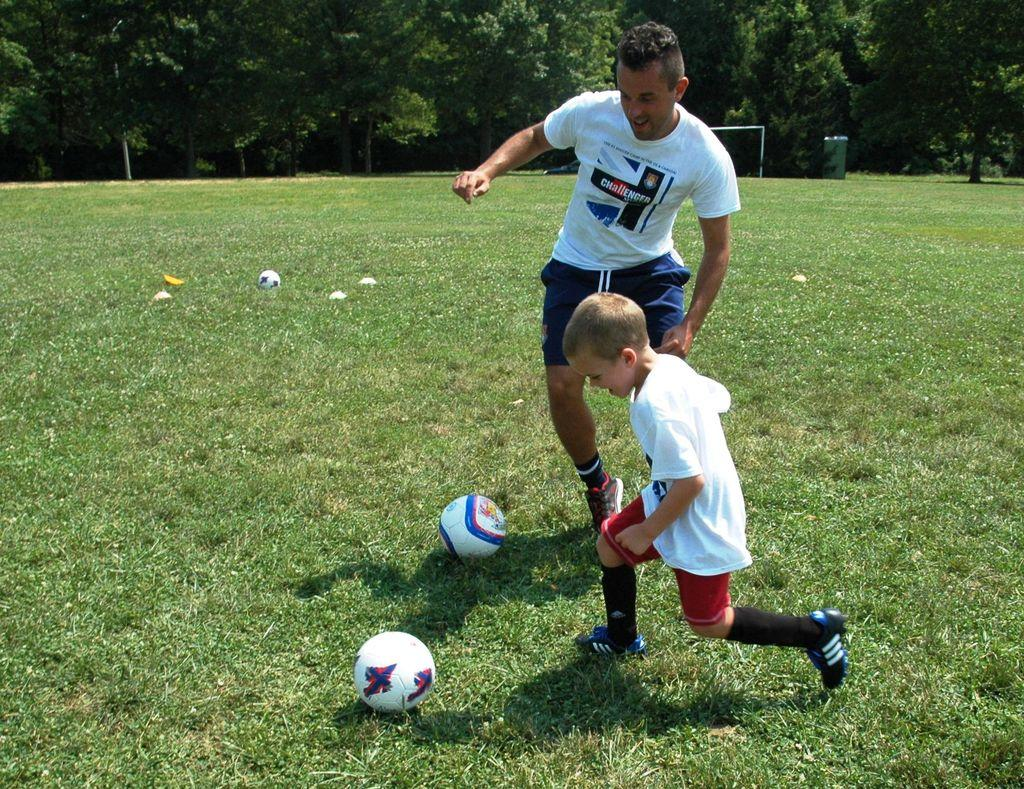What type of vegetation is at the bottom of the image? There is grass at the bottom of the image. Who or what can be seen in the middle of the image? There is a man and a kid in the middle of the image. What objects are on the ground in the image? There are three balls on the ground in the image. What can be seen in the background of the image? There are trees in the background of the image. What type of hose is being used to serve the meal in the image? There is no hose or meal present in the image. Can you see a ship in the background of the image? There is no ship visible in the image; only trees are present in the background. 